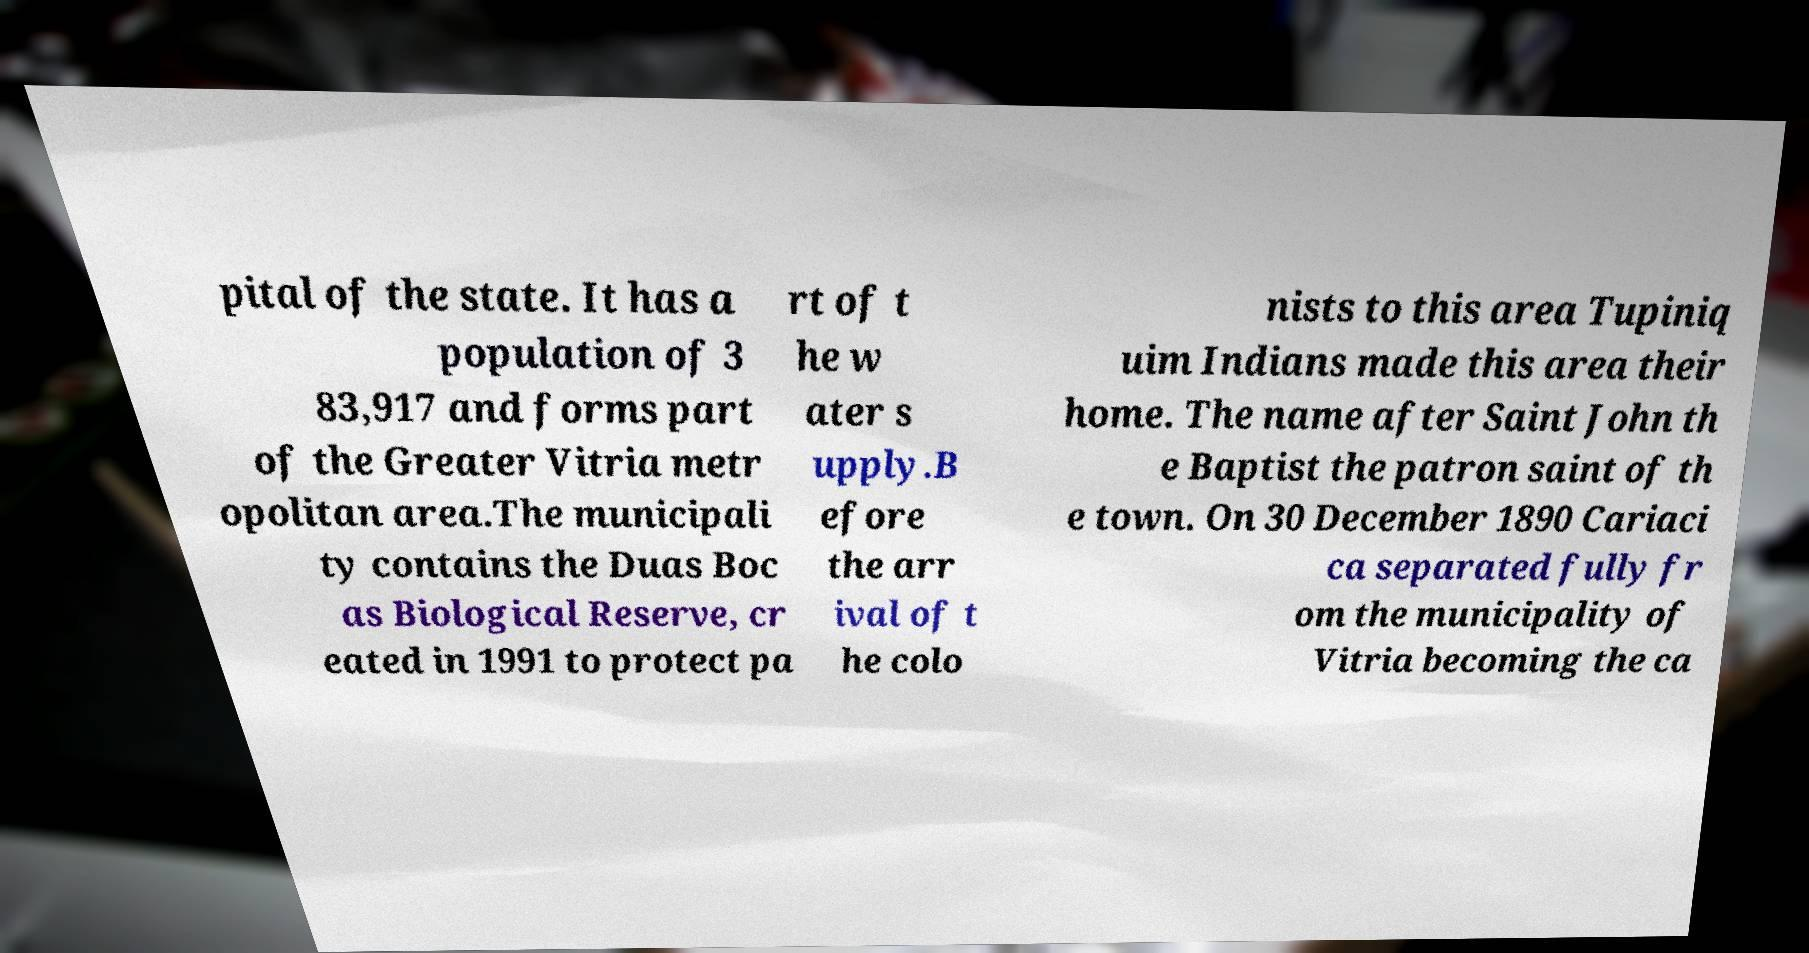For documentation purposes, I need the text within this image transcribed. Could you provide that? pital of the state. It has a population of 3 83,917 and forms part of the Greater Vitria metr opolitan area.The municipali ty contains the Duas Boc as Biological Reserve, cr eated in 1991 to protect pa rt of t he w ater s upply.B efore the arr ival of t he colo nists to this area Tupiniq uim Indians made this area their home. The name after Saint John th e Baptist the patron saint of th e town. On 30 December 1890 Cariaci ca separated fully fr om the municipality of Vitria becoming the ca 